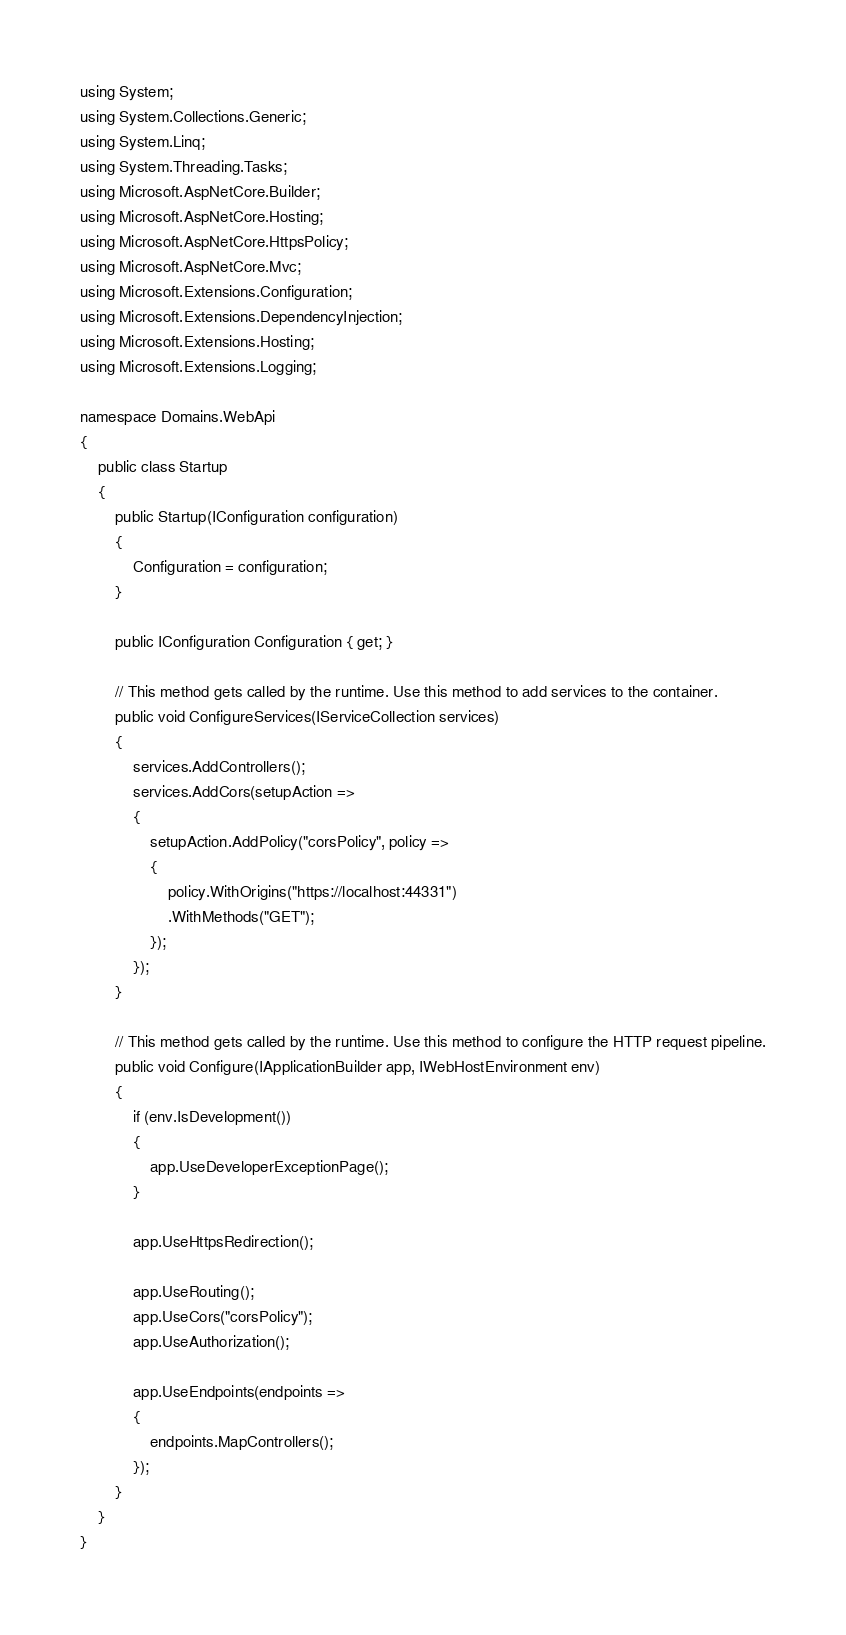Convert code to text. <code><loc_0><loc_0><loc_500><loc_500><_C#_>using System;
using System.Collections.Generic;
using System.Linq;
using System.Threading.Tasks;
using Microsoft.AspNetCore.Builder;
using Microsoft.AspNetCore.Hosting;
using Microsoft.AspNetCore.HttpsPolicy;
using Microsoft.AspNetCore.Mvc;
using Microsoft.Extensions.Configuration;
using Microsoft.Extensions.DependencyInjection;
using Microsoft.Extensions.Hosting;
using Microsoft.Extensions.Logging;

namespace Domains.WebApi
{
    public class Startup
    {
        public Startup(IConfiguration configuration)
        {
            Configuration = configuration;
        }

        public IConfiguration Configuration { get; }

        // This method gets called by the runtime. Use this method to add services to the container.
        public void ConfigureServices(IServiceCollection services)
        {
            services.AddControllers();
            services.AddCors(setupAction =>
            {
                setupAction.AddPolicy("corsPolicy", policy =>
                {
                    policy.WithOrigins("https://localhost:44331")
                    .WithMethods("GET");
                });
            });
        }

        // This method gets called by the runtime. Use this method to configure the HTTP request pipeline.
        public void Configure(IApplicationBuilder app, IWebHostEnvironment env)
        {
            if (env.IsDevelopment())
            {
                app.UseDeveloperExceptionPage();
            }

            app.UseHttpsRedirection();

            app.UseRouting();
            app.UseCors("corsPolicy");
            app.UseAuthorization();

            app.UseEndpoints(endpoints =>
            {
                endpoints.MapControllers();
            });
        }
    }
}
</code> 